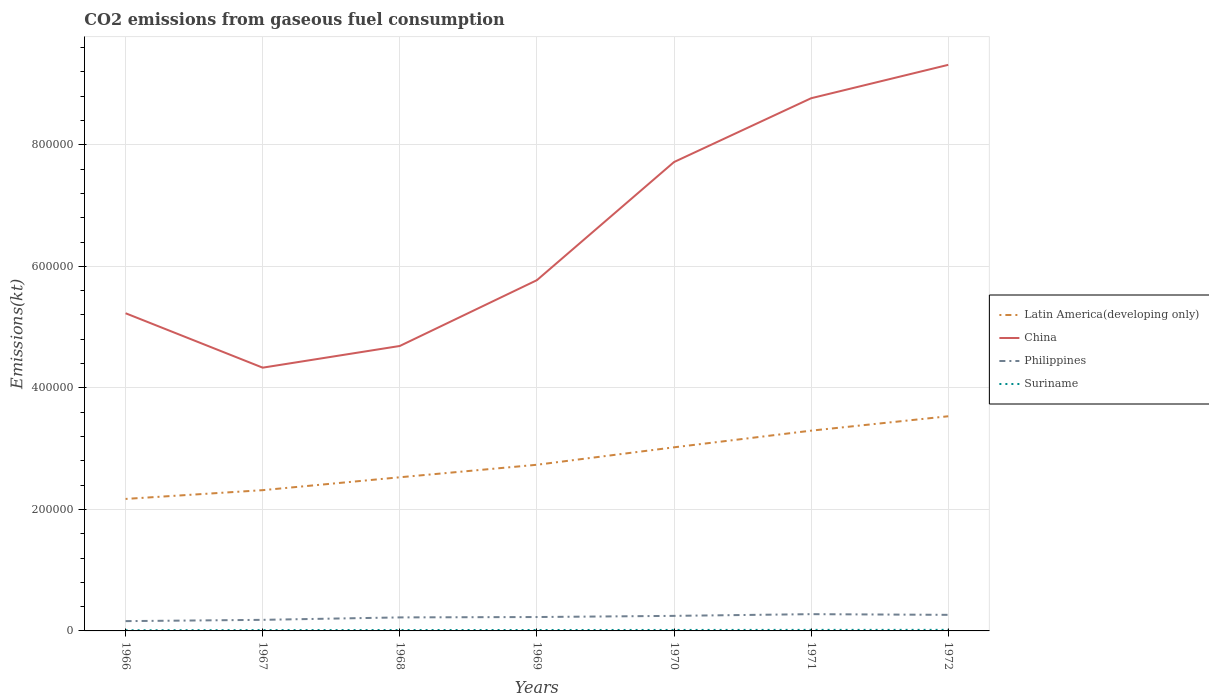How many different coloured lines are there?
Give a very brief answer. 4. Does the line corresponding to Philippines intersect with the line corresponding to China?
Offer a terse response. No. Across all years, what is the maximum amount of CO2 emitted in Latin America(developing only)?
Your response must be concise. 2.17e+05. In which year was the amount of CO2 emitted in Suriname maximum?
Offer a terse response. 1966. What is the total amount of CO2 emitted in Suriname in the graph?
Provide a succinct answer. -29.34. What is the difference between the highest and the second highest amount of CO2 emitted in Suriname?
Provide a succinct answer. 649.06. How many lines are there?
Keep it short and to the point. 4. How many years are there in the graph?
Offer a very short reply. 7. What is the difference between two consecutive major ticks on the Y-axis?
Your answer should be very brief. 2.00e+05. Are the values on the major ticks of Y-axis written in scientific E-notation?
Your response must be concise. No. Does the graph contain any zero values?
Your answer should be very brief. No. What is the title of the graph?
Your answer should be very brief. CO2 emissions from gaseous fuel consumption. What is the label or title of the Y-axis?
Provide a succinct answer. Emissions(kt). What is the Emissions(kt) in Latin America(developing only) in 1966?
Offer a terse response. 2.17e+05. What is the Emissions(kt) of China in 1966?
Provide a succinct answer. 5.23e+05. What is the Emissions(kt) of Philippines in 1966?
Make the answer very short. 1.61e+04. What is the Emissions(kt) of Suriname in 1966?
Provide a succinct answer. 1096.43. What is the Emissions(kt) of Latin America(developing only) in 1967?
Offer a terse response. 2.32e+05. What is the Emissions(kt) in China in 1967?
Make the answer very short. 4.33e+05. What is the Emissions(kt) in Philippines in 1967?
Keep it short and to the point. 1.82e+04. What is the Emissions(kt) in Suriname in 1967?
Your response must be concise. 1334.79. What is the Emissions(kt) of Latin America(developing only) in 1968?
Your answer should be very brief. 2.53e+05. What is the Emissions(kt) in China in 1968?
Provide a succinct answer. 4.69e+05. What is the Emissions(kt) in Philippines in 1968?
Give a very brief answer. 2.23e+04. What is the Emissions(kt) in Suriname in 1968?
Ensure brevity in your answer.  1452.13. What is the Emissions(kt) in Latin America(developing only) in 1969?
Keep it short and to the point. 2.73e+05. What is the Emissions(kt) of China in 1969?
Your answer should be compact. 5.77e+05. What is the Emissions(kt) of Philippines in 1969?
Your response must be concise. 2.29e+04. What is the Emissions(kt) of Suriname in 1969?
Provide a short and direct response. 1521.81. What is the Emissions(kt) of Latin America(developing only) in 1970?
Keep it short and to the point. 3.02e+05. What is the Emissions(kt) of China in 1970?
Your answer should be compact. 7.72e+05. What is the Emissions(kt) of Philippines in 1970?
Offer a very short reply. 2.48e+04. What is the Emissions(kt) of Suriname in 1970?
Provide a short and direct response. 1609.81. What is the Emissions(kt) of Latin America(developing only) in 1971?
Make the answer very short. 3.30e+05. What is the Emissions(kt) in China in 1971?
Ensure brevity in your answer.  8.77e+05. What is the Emissions(kt) of Philippines in 1971?
Offer a terse response. 2.76e+04. What is the Emissions(kt) of Suriname in 1971?
Your answer should be compact. 1716.16. What is the Emissions(kt) of Latin America(developing only) in 1972?
Ensure brevity in your answer.  3.53e+05. What is the Emissions(kt) in China in 1972?
Provide a short and direct response. 9.32e+05. What is the Emissions(kt) of Philippines in 1972?
Ensure brevity in your answer.  2.64e+04. What is the Emissions(kt) of Suriname in 1972?
Your answer should be compact. 1745.49. Across all years, what is the maximum Emissions(kt) of Latin America(developing only)?
Keep it short and to the point. 3.53e+05. Across all years, what is the maximum Emissions(kt) in China?
Provide a succinct answer. 9.32e+05. Across all years, what is the maximum Emissions(kt) of Philippines?
Keep it short and to the point. 2.76e+04. Across all years, what is the maximum Emissions(kt) in Suriname?
Offer a very short reply. 1745.49. Across all years, what is the minimum Emissions(kt) of Latin America(developing only)?
Offer a very short reply. 2.17e+05. Across all years, what is the minimum Emissions(kt) in China?
Ensure brevity in your answer.  4.33e+05. Across all years, what is the minimum Emissions(kt) in Philippines?
Offer a terse response. 1.61e+04. Across all years, what is the minimum Emissions(kt) of Suriname?
Offer a terse response. 1096.43. What is the total Emissions(kt) of Latin America(developing only) in the graph?
Offer a terse response. 1.96e+06. What is the total Emissions(kt) of China in the graph?
Offer a very short reply. 4.58e+06. What is the total Emissions(kt) of Philippines in the graph?
Provide a succinct answer. 1.58e+05. What is the total Emissions(kt) in Suriname in the graph?
Your answer should be very brief. 1.05e+04. What is the difference between the Emissions(kt) in Latin America(developing only) in 1966 and that in 1967?
Provide a succinct answer. -1.44e+04. What is the difference between the Emissions(kt) of China in 1966 and that in 1967?
Your answer should be very brief. 8.96e+04. What is the difference between the Emissions(kt) in Philippines in 1966 and that in 1967?
Offer a very short reply. -2108.53. What is the difference between the Emissions(kt) of Suriname in 1966 and that in 1967?
Offer a very short reply. -238.35. What is the difference between the Emissions(kt) in Latin America(developing only) in 1966 and that in 1968?
Ensure brevity in your answer.  -3.56e+04. What is the difference between the Emissions(kt) of China in 1966 and that in 1968?
Keep it short and to the point. 5.39e+04. What is the difference between the Emissions(kt) in Philippines in 1966 and that in 1968?
Provide a succinct answer. -6127.56. What is the difference between the Emissions(kt) in Suriname in 1966 and that in 1968?
Keep it short and to the point. -355.7. What is the difference between the Emissions(kt) of Latin America(developing only) in 1966 and that in 1969?
Offer a terse response. -5.62e+04. What is the difference between the Emissions(kt) in China in 1966 and that in 1969?
Your answer should be compact. -5.44e+04. What is the difference between the Emissions(kt) of Philippines in 1966 and that in 1969?
Ensure brevity in your answer.  -6736.28. What is the difference between the Emissions(kt) in Suriname in 1966 and that in 1969?
Ensure brevity in your answer.  -425.37. What is the difference between the Emissions(kt) in Latin America(developing only) in 1966 and that in 1970?
Give a very brief answer. -8.49e+04. What is the difference between the Emissions(kt) of China in 1966 and that in 1970?
Your response must be concise. -2.49e+05. What is the difference between the Emissions(kt) of Philippines in 1966 and that in 1970?
Keep it short and to the point. -8657.79. What is the difference between the Emissions(kt) in Suriname in 1966 and that in 1970?
Ensure brevity in your answer.  -513.38. What is the difference between the Emissions(kt) in Latin America(developing only) in 1966 and that in 1971?
Offer a terse response. -1.12e+05. What is the difference between the Emissions(kt) of China in 1966 and that in 1971?
Your answer should be compact. -3.54e+05. What is the difference between the Emissions(kt) of Philippines in 1966 and that in 1971?
Your answer should be compact. -1.15e+04. What is the difference between the Emissions(kt) of Suriname in 1966 and that in 1971?
Your response must be concise. -619.72. What is the difference between the Emissions(kt) of Latin America(developing only) in 1966 and that in 1972?
Make the answer very short. -1.36e+05. What is the difference between the Emissions(kt) in China in 1966 and that in 1972?
Provide a short and direct response. -4.09e+05. What is the difference between the Emissions(kt) of Philippines in 1966 and that in 1972?
Make the answer very short. -1.03e+04. What is the difference between the Emissions(kt) of Suriname in 1966 and that in 1972?
Your response must be concise. -649.06. What is the difference between the Emissions(kt) of Latin America(developing only) in 1967 and that in 1968?
Offer a terse response. -2.12e+04. What is the difference between the Emissions(kt) of China in 1967 and that in 1968?
Offer a terse response. -3.57e+04. What is the difference between the Emissions(kt) of Philippines in 1967 and that in 1968?
Offer a terse response. -4019.03. What is the difference between the Emissions(kt) in Suriname in 1967 and that in 1968?
Make the answer very short. -117.34. What is the difference between the Emissions(kt) of Latin America(developing only) in 1967 and that in 1969?
Make the answer very short. -4.18e+04. What is the difference between the Emissions(kt) in China in 1967 and that in 1969?
Ensure brevity in your answer.  -1.44e+05. What is the difference between the Emissions(kt) of Philippines in 1967 and that in 1969?
Provide a succinct answer. -4627.75. What is the difference between the Emissions(kt) in Suriname in 1967 and that in 1969?
Offer a very short reply. -187.02. What is the difference between the Emissions(kt) of Latin America(developing only) in 1967 and that in 1970?
Keep it short and to the point. -7.05e+04. What is the difference between the Emissions(kt) of China in 1967 and that in 1970?
Provide a succinct answer. -3.38e+05. What is the difference between the Emissions(kt) of Philippines in 1967 and that in 1970?
Keep it short and to the point. -6549.26. What is the difference between the Emissions(kt) in Suriname in 1967 and that in 1970?
Offer a terse response. -275.02. What is the difference between the Emissions(kt) in Latin America(developing only) in 1967 and that in 1971?
Provide a short and direct response. -9.79e+04. What is the difference between the Emissions(kt) of China in 1967 and that in 1971?
Give a very brief answer. -4.43e+05. What is the difference between the Emissions(kt) in Philippines in 1967 and that in 1971?
Give a very brief answer. -9354.52. What is the difference between the Emissions(kt) in Suriname in 1967 and that in 1971?
Provide a short and direct response. -381.37. What is the difference between the Emissions(kt) in Latin America(developing only) in 1967 and that in 1972?
Provide a succinct answer. -1.22e+05. What is the difference between the Emissions(kt) of China in 1967 and that in 1972?
Offer a terse response. -4.98e+05. What is the difference between the Emissions(kt) of Philippines in 1967 and that in 1972?
Provide a succinct answer. -8210.41. What is the difference between the Emissions(kt) in Suriname in 1967 and that in 1972?
Make the answer very short. -410.7. What is the difference between the Emissions(kt) in Latin America(developing only) in 1968 and that in 1969?
Give a very brief answer. -2.06e+04. What is the difference between the Emissions(kt) in China in 1968 and that in 1969?
Give a very brief answer. -1.08e+05. What is the difference between the Emissions(kt) in Philippines in 1968 and that in 1969?
Provide a short and direct response. -608.72. What is the difference between the Emissions(kt) in Suriname in 1968 and that in 1969?
Provide a succinct answer. -69.67. What is the difference between the Emissions(kt) in Latin America(developing only) in 1968 and that in 1970?
Your answer should be compact. -4.93e+04. What is the difference between the Emissions(kt) in China in 1968 and that in 1970?
Keep it short and to the point. -3.03e+05. What is the difference between the Emissions(kt) in Philippines in 1968 and that in 1970?
Your response must be concise. -2530.23. What is the difference between the Emissions(kt) in Suriname in 1968 and that in 1970?
Ensure brevity in your answer.  -157.68. What is the difference between the Emissions(kt) in Latin America(developing only) in 1968 and that in 1971?
Keep it short and to the point. -7.67e+04. What is the difference between the Emissions(kt) of China in 1968 and that in 1971?
Provide a succinct answer. -4.08e+05. What is the difference between the Emissions(kt) of Philippines in 1968 and that in 1971?
Provide a succinct answer. -5335.48. What is the difference between the Emissions(kt) of Suriname in 1968 and that in 1971?
Make the answer very short. -264.02. What is the difference between the Emissions(kt) in Latin America(developing only) in 1968 and that in 1972?
Offer a very short reply. -1.00e+05. What is the difference between the Emissions(kt) of China in 1968 and that in 1972?
Provide a succinct answer. -4.63e+05. What is the difference between the Emissions(kt) in Philippines in 1968 and that in 1972?
Your response must be concise. -4191.38. What is the difference between the Emissions(kt) in Suriname in 1968 and that in 1972?
Offer a very short reply. -293.36. What is the difference between the Emissions(kt) in Latin America(developing only) in 1969 and that in 1970?
Your answer should be very brief. -2.87e+04. What is the difference between the Emissions(kt) of China in 1969 and that in 1970?
Provide a succinct answer. -1.94e+05. What is the difference between the Emissions(kt) in Philippines in 1969 and that in 1970?
Ensure brevity in your answer.  -1921.51. What is the difference between the Emissions(kt) in Suriname in 1969 and that in 1970?
Keep it short and to the point. -88.01. What is the difference between the Emissions(kt) in Latin America(developing only) in 1969 and that in 1971?
Provide a succinct answer. -5.61e+04. What is the difference between the Emissions(kt) in China in 1969 and that in 1971?
Make the answer very short. -2.99e+05. What is the difference between the Emissions(kt) of Philippines in 1969 and that in 1971?
Keep it short and to the point. -4726.76. What is the difference between the Emissions(kt) in Suriname in 1969 and that in 1971?
Your response must be concise. -194.35. What is the difference between the Emissions(kt) of Latin America(developing only) in 1969 and that in 1972?
Keep it short and to the point. -7.98e+04. What is the difference between the Emissions(kt) of China in 1969 and that in 1972?
Give a very brief answer. -3.54e+05. What is the difference between the Emissions(kt) in Philippines in 1969 and that in 1972?
Provide a short and direct response. -3582.66. What is the difference between the Emissions(kt) in Suriname in 1969 and that in 1972?
Your response must be concise. -223.69. What is the difference between the Emissions(kt) in Latin America(developing only) in 1970 and that in 1971?
Provide a short and direct response. -2.74e+04. What is the difference between the Emissions(kt) of China in 1970 and that in 1971?
Give a very brief answer. -1.05e+05. What is the difference between the Emissions(kt) in Philippines in 1970 and that in 1971?
Your answer should be very brief. -2805.26. What is the difference between the Emissions(kt) of Suriname in 1970 and that in 1971?
Give a very brief answer. -106.34. What is the difference between the Emissions(kt) in Latin America(developing only) in 1970 and that in 1972?
Make the answer very short. -5.11e+04. What is the difference between the Emissions(kt) in China in 1970 and that in 1972?
Offer a very short reply. -1.60e+05. What is the difference between the Emissions(kt) in Philippines in 1970 and that in 1972?
Keep it short and to the point. -1661.15. What is the difference between the Emissions(kt) of Suriname in 1970 and that in 1972?
Keep it short and to the point. -135.68. What is the difference between the Emissions(kt) of Latin America(developing only) in 1971 and that in 1972?
Your response must be concise. -2.37e+04. What is the difference between the Emissions(kt) of China in 1971 and that in 1972?
Your response must be concise. -5.49e+04. What is the difference between the Emissions(kt) of Philippines in 1971 and that in 1972?
Provide a succinct answer. 1144.1. What is the difference between the Emissions(kt) of Suriname in 1971 and that in 1972?
Keep it short and to the point. -29.34. What is the difference between the Emissions(kt) in Latin America(developing only) in 1966 and the Emissions(kt) in China in 1967?
Ensure brevity in your answer.  -2.16e+05. What is the difference between the Emissions(kt) of Latin America(developing only) in 1966 and the Emissions(kt) of Philippines in 1967?
Give a very brief answer. 1.99e+05. What is the difference between the Emissions(kt) in Latin America(developing only) in 1966 and the Emissions(kt) in Suriname in 1967?
Your answer should be compact. 2.16e+05. What is the difference between the Emissions(kt) in China in 1966 and the Emissions(kt) in Philippines in 1967?
Your answer should be compact. 5.05e+05. What is the difference between the Emissions(kt) in China in 1966 and the Emissions(kt) in Suriname in 1967?
Offer a very short reply. 5.21e+05. What is the difference between the Emissions(kt) of Philippines in 1966 and the Emissions(kt) of Suriname in 1967?
Offer a very short reply. 1.48e+04. What is the difference between the Emissions(kt) of Latin America(developing only) in 1966 and the Emissions(kt) of China in 1968?
Give a very brief answer. -2.52e+05. What is the difference between the Emissions(kt) of Latin America(developing only) in 1966 and the Emissions(kt) of Philippines in 1968?
Provide a succinct answer. 1.95e+05. What is the difference between the Emissions(kt) of Latin America(developing only) in 1966 and the Emissions(kt) of Suriname in 1968?
Ensure brevity in your answer.  2.16e+05. What is the difference between the Emissions(kt) in China in 1966 and the Emissions(kt) in Philippines in 1968?
Your answer should be compact. 5.01e+05. What is the difference between the Emissions(kt) of China in 1966 and the Emissions(kt) of Suriname in 1968?
Keep it short and to the point. 5.21e+05. What is the difference between the Emissions(kt) of Philippines in 1966 and the Emissions(kt) of Suriname in 1968?
Give a very brief answer. 1.47e+04. What is the difference between the Emissions(kt) in Latin America(developing only) in 1966 and the Emissions(kt) in China in 1969?
Ensure brevity in your answer.  -3.60e+05. What is the difference between the Emissions(kt) of Latin America(developing only) in 1966 and the Emissions(kt) of Philippines in 1969?
Give a very brief answer. 1.94e+05. What is the difference between the Emissions(kt) of Latin America(developing only) in 1966 and the Emissions(kt) of Suriname in 1969?
Keep it short and to the point. 2.16e+05. What is the difference between the Emissions(kt) in China in 1966 and the Emissions(kt) in Philippines in 1969?
Your answer should be very brief. 5.00e+05. What is the difference between the Emissions(kt) in China in 1966 and the Emissions(kt) in Suriname in 1969?
Your answer should be compact. 5.21e+05. What is the difference between the Emissions(kt) of Philippines in 1966 and the Emissions(kt) of Suriname in 1969?
Make the answer very short. 1.46e+04. What is the difference between the Emissions(kt) of Latin America(developing only) in 1966 and the Emissions(kt) of China in 1970?
Give a very brief answer. -5.54e+05. What is the difference between the Emissions(kt) in Latin America(developing only) in 1966 and the Emissions(kt) in Philippines in 1970?
Keep it short and to the point. 1.92e+05. What is the difference between the Emissions(kt) of Latin America(developing only) in 1966 and the Emissions(kt) of Suriname in 1970?
Make the answer very short. 2.16e+05. What is the difference between the Emissions(kt) in China in 1966 and the Emissions(kt) in Philippines in 1970?
Your answer should be compact. 4.98e+05. What is the difference between the Emissions(kt) in China in 1966 and the Emissions(kt) in Suriname in 1970?
Your response must be concise. 5.21e+05. What is the difference between the Emissions(kt) of Philippines in 1966 and the Emissions(kt) of Suriname in 1970?
Your response must be concise. 1.45e+04. What is the difference between the Emissions(kt) in Latin America(developing only) in 1966 and the Emissions(kt) in China in 1971?
Ensure brevity in your answer.  -6.59e+05. What is the difference between the Emissions(kt) in Latin America(developing only) in 1966 and the Emissions(kt) in Philippines in 1971?
Provide a short and direct response. 1.90e+05. What is the difference between the Emissions(kt) of Latin America(developing only) in 1966 and the Emissions(kt) of Suriname in 1971?
Offer a very short reply. 2.15e+05. What is the difference between the Emissions(kt) of China in 1966 and the Emissions(kt) of Philippines in 1971?
Offer a very short reply. 4.95e+05. What is the difference between the Emissions(kt) of China in 1966 and the Emissions(kt) of Suriname in 1971?
Ensure brevity in your answer.  5.21e+05. What is the difference between the Emissions(kt) of Philippines in 1966 and the Emissions(kt) of Suriname in 1971?
Keep it short and to the point. 1.44e+04. What is the difference between the Emissions(kt) in Latin America(developing only) in 1966 and the Emissions(kt) in China in 1972?
Give a very brief answer. -7.14e+05. What is the difference between the Emissions(kt) of Latin America(developing only) in 1966 and the Emissions(kt) of Philippines in 1972?
Provide a succinct answer. 1.91e+05. What is the difference between the Emissions(kt) of Latin America(developing only) in 1966 and the Emissions(kt) of Suriname in 1972?
Provide a succinct answer. 2.15e+05. What is the difference between the Emissions(kt) in China in 1966 and the Emissions(kt) in Philippines in 1972?
Offer a terse response. 4.96e+05. What is the difference between the Emissions(kt) in China in 1966 and the Emissions(kt) in Suriname in 1972?
Keep it short and to the point. 5.21e+05. What is the difference between the Emissions(kt) in Philippines in 1966 and the Emissions(kt) in Suriname in 1972?
Provide a short and direct response. 1.44e+04. What is the difference between the Emissions(kt) of Latin America(developing only) in 1967 and the Emissions(kt) of China in 1968?
Provide a short and direct response. -2.37e+05. What is the difference between the Emissions(kt) of Latin America(developing only) in 1967 and the Emissions(kt) of Philippines in 1968?
Offer a very short reply. 2.09e+05. What is the difference between the Emissions(kt) in Latin America(developing only) in 1967 and the Emissions(kt) in Suriname in 1968?
Your response must be concise. 2.30e+05. What is the difference between the Emissions(kt) in China in 1967 and the Emissions(kt) in Philippines in 1968?
Offer a terse response. 4.11e+05. What is the difference between the Emissions(kt) of China in 1967 and the Emissions(kt) of Suriname in 1968?
Offer a very short reply. 4.32e+05. What is the difference between the Emissions(kt) of Philippines in 1967 and the Emissions(kt) of Suriname in 1968?
Your answer should be compact. 1.68e+04. What is the difference between the Emissions(kt) of Latin America(developing only) in 1967 and the Emissions(kt) of China in 1969?
Provide a succinct answer. -3.46e+05. What is the difference between the Emissions(kt) of Latin America(developing only) in 1967 and the Emissions(kt) of Philippines in 1969?
Keep it short and to the point. 2.09e+05. What is the difference between the Emissions(kt) of Latin America(developing only) in 1967 and the Emissions(kt) of Suriname in 1969?
Your response must be concise. 2.30e+05. What is the difference between the Emissions(kt) in China in 1967 and the Emissions(kt) in Philippines in 1969?
Keep it short and to the point. 4.10e+05. What is the difference between the Emissions(kt) in China in 1967 and the Emissions(kt) in Suriname in 1969?
Give a very brief answer. 4.32e+05. What is the difference between the Emissions(kt) of Philippines in 1967 and the Emissions(kt) of Suriname in 1969?
Provide a succinct answer. 1.67e+04. What is the difference between the Emissions(kt) of Latin America(developing only) in 1967 and the Emissions(kt) of China in 1970?
Provide a succinct answer. -5.40e+05. What is the difference between the Emissions(kt) in Latin America(developing only) in 1967 and the Emissions(kt) in Philippines in 1970?
Your response must be concise. 2.07e+05. What is the difference between the Emissions(kt) of Latin America(developing only) in 1967 and the Emissions(kt) of Suriname in 1970?
Ensure brevity in your answer.  2.30e+05. What is the difference between the Emissions(kt) in China in 1967 and the Emissions(kt) in Philippines in 1970?
Provide a short and direct response. 4.08e+05. What is the difference between the Emissions(kt) of China in 1967 and the Emissions(kt) of Suriname in 1970?
Offer a very short reply. 4.32e+05. What is the difference between the Emissions(kt) in Philippines in 1967 and the Emissions(kt) in Suriname in 1970?
Your answer should be very brief. 1.66e+04. What is the difference between the Emissions(kt) of Latin America(developing only) in 1967 and the Emissions(kt) of China in 1971?
Make the answer very short. -6.45e+05. What is the difference between the Emissions(kt) of Latin America(developing only) in 1967 and the Emissions(kt) of Philippines in 1971?
Your answer should be very brief. 2.04e+05. What is the difference between the Emissions(kt) in Latin America(developing only) in 1967 and the Emissions(kt) in Suriname in 1971?
Offer a very short reply. 2.30e+05. What is the difference between the Emissions(kt) of China in 1967 and the Emissions(kt) of Philippines in 1971?
Provide a succinct answer. 4.06e+05. What is the difference between the Emissions(kt) in China in 1967 and the Emissions(kt) in Suriname in 1971?
Provide a short and direct response. 4.32e+05. What is the difference between the Emissions(kt) of Philippines in 1967 and the Emissions(kt) of Suriname in 1971?
Offer a terse response. 1.65e+04. What is the difference between the Emissions(kt) in Latin America(developing only) in 1967 and the Emissions(kt) in China in 1972?
Provide a short and direct response. -7.00e+05. What is the difference between the Emissions(kt) of Latin America(developing only) in 1967 and the Emissions(kt) of Philippines in 1972?
Offer a very short reply. 2.05e+05. What is the difference between the Emissions(kt) of Latin America(developing only) in 1967 and the Emissions(kt) of Suriname in 1972?
Ensure brevity in your answer.  2.30e+05. What is the difference between the Emissions(kt) of China in 1967 and the Emissions(kt) of Philippines in 1972?
Your response must be concise. 4.07e+05. What is the difference between the Emissions(kt) of China in 1967 and the Emissions(kt) of Suriname in 1972?
Ensure brevity in your answer.  4.31e+05. What is the difference between the Emissions(kt) in Philippines in 1967 and the Emissions(kt) in Suriname in 1972?
Keep it short and to the point. 1.65e+04. What is the difference between the Emissions(kt) of Latin America(developing only) in 1968 and the Emissions(kt) of China in 1969?
Offer a very short reply. -3.24e+05. What is the difference between the Emissions(kt) of Latin America(developing only) in 1968 and the Emissions(kt) of Philippines in 1969?
Provide a succinct answer. 2.30e+05. What is the difference between the Emissions(kt) in Latin America(developing only) in 1968 and the Emissions(kt) in Suriname in 1969?
Make the answer very short. 2.51e+05. What is the difference between the Emissions(kt) in China in 1968 and the Emissions(kt) in Philippines in 1969?
Ensure brevity in your answer.  4.46e+05. What is the difference between the Emissions(kt) of China in 1968 and the Emissions(kt) of Suriname in 1969?
Give a very brief answer. 4.67e+05. What is the difference between the Emissions(kt) in Philippines in 1968 and the Emissions(kt) in Suriname in 1969?
Make the answer very short. 2.07e+04. What is the difference between the Emissions(kt) in Latin America(developing only) in 1968 and the Emissions(kt) in China in 1970?
Your answer should be very brief. -5.19e+05. What is the difference between the Emissions(kt) in Latin America(developing only) in 1968 and the Emissions(kt) in Philippines in 1970?
Give a very brief answer. 2.28e+05. What is the difference between the Emissions(kt) of Latin America(developing only) in 1968 and the Emissions(kt) of Suriname in 1970?
Offer a very short reply. 2.51e+05. What is the difference between the Emissions(kt) of China in 1968 and the Emissions(kt) of Philippines in 1970?
Provide a succinct answer. 4.44e+05. What is the difference between the Emissions(kt) in China in 1968 and the Emissions(kt) in Suriname in 1970?
Offer a very short reply. 4.67e+05. What is the difference between the Emissions(kt) of Philippines in 1968 and the Emissions(kt) of Suriname in 1970?
Offer a terse response. 2.06e+04. What is the difference between the Emissions(kt) in Latin America(developing only) in 1968 and the Emissions(kt) in China in 1971?
Provide a succinct answer. -6.24e+05. What is the difference between the Emissions(kt) in Latin America(developing only) in 1968 and the Emissions(kt) in Philippines in 1971?
Offer a terse response. 2.25e+05. What is the difference between the Emissions(kt) in Latin America(developing only) in 1968 and the Emissions(kt) in Suriname in 1971?
Provide a short and direct response. 2.51e+05. What is the difference between the Emissions(kt) in China in 1968 and the Emissions(kt) in Philippines in 1971?
Keep it short and to the point. 4.41e+05. What is the difference between the Emissions(kt) in China in 1968 and the Emissions(kt) in Suriname in 1971?
Your answer should be very brief. 4.67e+05. What is the difference between the Emissions(kt) of Philippines in 1968 and the Emissions(kt) of Suriname in 1971?
Provide a short and direct response. 2.05e+04. What is the difference between the Emissions(kt) in Latin America(developing only) in 1968 and the Emissions(kt) in China in 1972?
Your answer should be very brief. -6.79e+05. What is the difference between the Emissions(kt) of Latin America(developing only) in 1968 and the Emissions(kt) of Philippines in 1972?
Your answer should be very brief. 2.26e+05. What is the difference between the Emissions(kt) in Latin America(developing only) in 1968 and the Emissions(kt) in Suriname in 1972?
Make the answer very short. 2.51e+05. What is the difference between the Emissions(kt) in China in 1968 and the Emissions(kt) in Philippines in 1972?
Keep it short and to the point. 4.42e+05. What is the difference between the Emissions(kt) in China in 1968 and the Emissions(kt) in Suriname in 1972?
Make the answer very short. 4.67e+05. What is the difference between the Emissions(kt) of Philippines in 1968 and the Emissions(kt) of Suriname in 1972?
Make the answer very short. 2.05e+04. What is the difference between the Emissions(kt) in Latin America(developing only) in 1969 and the Emissions(kt) in China in 1970?
Provide a succinct answer. -4.98e+05. What is the difference between the Emissions(kt) in Latin America(developing only) in 1969 and the Emissions(kt) in Philippines in 1970?
Offer a very short reply. 2.49e+05. What is the difference between the Emissions(kt) in Latin America(developing only) in 1969 and the Emissions(kt) in Suriname in 1970?
Offer a very short reply. 2.72e+05. What is the difference between the Emissions(kt) in China in 1969 and the Emissions(kt) in Philippines in 1970?
Provide a short and direct response. 5.52e+05. What is the difference between the Emissions(kt) of China in 1969 and the Emissions(kt) of Suriname in 1970?
Make the answer very short. 5.76e+05. What is the difference between the Emissions(kt) in Philippines in 1969 and the Emissions(kt) in Suriname in 1970?
Give a very brief answer. 2.13e+04. What is the difference between the Emissions(kt) in Latin America(developing only) in 1969 and the Emissions(kt) in China in 1971?
Your answer should be compact. -6.03e+05. What is the difference between the Emissions(kt) of Latin America(developing only) in 1969 and the Emissions(kt) of Philippines in 1971?
Keep it short and to the point. 2.46e+05. What is the difference between the Emissions(kt) in Latin America(developing only) in 1969 and the Emissions(kt) in Suriname in 1971?
Your answer should be very brief. 2.72e+05. What is the difference between the Emissions(kt) in China in 1969 and the Emissions(kt) in Philippines in 1971?
Your answer should be compact. 5.50e+05. What is the difference between the Emissions(kt) of China in 1969 and the Emissions(kt) of Suriname in 1971?
Keep it short and to the point. 5.76e+05. What is the difference between the Emissions(kt) in Philippines in 1969 and the Emissions(kt) in Suriname in 1971?
Provide a succinct answer. 2.11e+04. What is the difference between the Emissions(kt) of Latin America(developing only) in 1969 and the Emissions(kt) of China in 1972?
Your answer should be very brief. -6.58e+05. What is the difference between the Emissions(kt) in Latin America(developing only) in 1969 and the Emissions(kt) in Philippines in 1972?
Keep it short and to the point. 2.47e+05. What is the difference between the Emissions(kt) of Latin America(developing only) in 1969 and the Emissions(kt) of Suriname in 1972?
Provide a short and direct response. 2.72e+05. What is the difference between the Emissions(kt) in China in 1969 and the Emissions(kt) in Philippines in 1972?
Your response must be concise. 5.51e+05. What is the difference between the Emissions(kt) of China in 1969 and the Emissions(kt) of Suriname in 1972?
Your response must be concise. 5.75e+05. What is the difference between the Emissions(kt) in Philippines in 1969 and the Emissions(kt) in Suriname in 1972?
Ensure brevity in your answer.  2.11e+04. What is the difference between the Emissions(kt) of Latin America(developing only) in 1970 and the Emissions(kt) of China in 1971?
Your response must be concise. -5.74e+05. What is the difference between the Emissions(kt) in Latin America(developing only) in 1970 and the Emissions(kt) in Philippines in 1971?
Make the answer very short. 2.75e+05. What is the difference between the Emissions(kt) of Latin America(developing only) in 1970 and the Emissions(kt) of Suriname in 1971?
Give a very brief answer. 3.00e+05. What is the difference between the Emissions(kt) of China in 1970 and the Emissions(kt) of Philippines in 1971?
Offer a terse response. 7.44e+05. What is the difference between the Emissions(kt) of China in 1970 and the Emissions(kt) of Suriname in 1971?
Keep it short and to the point. 7.70e+05. What is the difference between the Emissions(kt) in Philippines in 1970 and the Emissions(kt) in Suriname in 1971?
Ensure brevity in your answer.  2.31e+04. What is the difference between the Emissions(kt) of Latin America(developing only) in 1970 and the Emissions(kt) of China in 1972?
Your response must be concise. -6.29e+05. What is the difference between the Emissions(kt) of Latin America(developing only) in 1970 and the Emissions(kt) of Philippines in 1972?
Make the answer very short. 2.76e+05. What is the difference between the Emissions(kt) in Latin America(developing only) in 1970 and the Emissions(kt) in Suriname in 1972?
Offer a terse response. 3.00e+05. What is the difference between the Emissions(kt) in China in 1970 and the Emissions(kt) in Philippines in 1972?
Offer a very short reply. 7.45e+05. What is the difference between the Emissions(kt) in China in 1970 and the Emissions(kt) in Suriname in 1972?
Make the answer very short. 7.70e+05. What is the difference between the Emissions(kt) of Philippines in 1970 and the Emissions(kt) of Suriname in 1972?
Your answer should be very brief. 2.30e+04. What is the difference between the Emissions(kt) in Latin America(developing only) in 1971 and the Emissions(kt) in China in 1972?
Your answer should be very brief. -6.02e+05. What is the difference between the Emissions(kt) of Latin America(developing only) in 1971 and the Emissions(kt) of Philippines in 1972?
Provide a short and direct response. 3.03e+05. What is the difference between the Emissions(kt) of Latin America(developing only) in 1971 and the Emissions(kt) of Suriname in 1972?
Offer a terse response. 3.28e+05. What is the difference between the Emissions(kt) in China in 1971 and the Emissions(kt) in Philippines in 1972?
Give a very brief answer. 8.50e+05. What is the difference between the Emissions(kt) in China in 1971 and the Emissions(kt) in Suriname in 1972?
Your answer should be compact. 8.75e+05. What is the difference between the Emissions(kt) in Philippines in 1971 and the Emissions(kt) in Suriname in 1972?
Your response must be concise. 2.58e+04. What is the average Emissions(kt) in Latin America(developing only) per year?
Give a very brief answer. 2.80e+05. What is the average Emissions(kt) of China per year?
Make the answer very short. 6.55e+05. What is the average Emissions(kt) in Philippines per year?
Your answer should be compact. 2.26e+04. What is the average Emissions(kt) in Suriname per year?
Your response must be concise. 1496.66. In the year 1966, what is the difference between the Emissions(kt) of Latin America(developing only) and Emissions(kt) of China?
Your answer should be very brief. -3.06e+05. In the year 1966, what is the difference between the Emissions(kt) of Latin America(developing only) and Emissions(kt) of Philippines?
Your answer should be compact. 2.01e+05. In the year 1966, what is the difference between the Emissions(kt) of Latin America(developing only) and Emissions(kt) of Suriname?
Provide a succinct answer. 2.16e+05. In the year 1966, what is the difference between the Emissions(kt) in China and Emissions(kt) in Philippines?
Offer a terse response. 5.07e+05. In the year 1966, what is the difference between the Emissions(kt) in China and Emissions(kt) in Suriname?
Provide a short and direct response. 5.22e+05. In the year 1966, what is the difference between the Emissions(kt) in Philippines and Emissions(kt) in Suriname?
Provide a short and direct response. 1.50e+04. In the year 1967, what is the difference between the Emissions(kt) of Latin America(developing only) and Emissions(kt) of China?
Keep it short and to the point. -2.02e+05. In the year 1967, what is the difference between the Emissions(kt) in Latin America(developing only) and Emissions(kt) in Philippines?
Provide a short and direct response. 2.13e+05. In the year 1967, what is the difference between the Emissions(kt) in Latin America(developing only) and Emissions(kt) in Suriname?
Your answer should be compact. 2.30e+05. In the year 1967, what is the difference between the Emissions(kt) of China and Emissions(kt) of Philippines?
Offer a terse response. 4.15e+05. In the year 1967, what is the difference between the Emissions(kt) of China and Emissions(kt) of Suriname?
Offer a very short reply. 4.32e+05. In the year 1967, what is the difference between the Emissions(kt) in Philippines and Emissions(kt) in Suriname?
Give a very brief answer. 1.69e+04. In the year 1968, what is the difference between the Emissions(kt) of Latin America(developing only) and Emissions(kt) of China?
Keep it short and to the point. -2.16e+05. In the year 1968, what is the difference between the Emissions(kt) in Latin America(developing only) and Emissions(kt) in Philippines?
Your response must be concise. 2.31e+05. In the year 1968, what is the difference between the Emissions(kt) of Latin America(developing only) and Emissions(kt) of Suriname?
Ensure brevity in your answer.  2.51e+05. In the year 1968, what is the difference between the Emissions(kt) in China and Emissions(kt) in Philippines?
Keep it short and to the point. 4.47e+05. In the year 1968, what is the difference between the Emissions(kt) in China and Emissions(kt) in Suriname?
Provide a short and direct response. 4.67e+05. In the year 1968, what is the difference between the Emissions(kt) of Philippines and Emissions(kt) of Suriname?
Your response must be concise. 2.08e+04. In the year 1969, what is the difference between the Emissions(kt) of Latin America(developing only) and Emissions(kt) of China?
Provide a short and direct response. -3.04e+05. In the year 1969, what is the difference between the Emissions(kt) of Latin America(developing only) and Emissions(kt) of Philippines?
Your answer should be compact. 2.51e+05. In the year 1969, what is the difference between the Emissions(kt) in Latin America(developing only) and Emissions(kt) in Suriname?
Provide a succinct answer. 2.72e+05. In the year 1969, what is the difference between the Emissions(kt) in China and Emissions(kt) in Philippines?
Keep it short and to the point. 5.54e+05. In the year 1969, what is the difference between the Emissions(kt) of China and Emissions(kt) of Suriname?
Your response must be concise. 5.76e+05. In the year 1969, what is the difference between the Emissions(kt) in Philippines and Emissions(kt) in Suriname?
Your answer should be compact. 2.13e+04. In the year 1970, what is the difference between the Emissions(kt) of Latin America(developing only) and Emissions(kt) of China?
Provide a succinct answer. -4.69e+05. In the year 1970, what is the difference between the Emissions(kt) of Latin America(developing only) and Emissions(kt) of Philippines?
Provide a short and direct response. 2.77e+05. In the year 1970, what is the difference between the Emissions(kt) of Latin America(developing only) and Emissions(kt) of Suriname?
Make the answer very short. 3.01e+05. In the year 1970, what is the difference between the Emissions(kt) of China and Emissions(kt) of Philippines?
Your answer should be very brief. 7.47e+05. In the year 1970, what is the difference between the Emissions(kt) of China and Emissions(kt) of Suriname?
Offer a terse response. 7.70e+05. In the year 1970, what is the difference between the Emissions(kt) in Philippines and Emissions(kt) in Suriname?
Make the answer very short. 2.32e+04. In the year 1971, what is the difference between the Emissions(kt) in Latin America(developing only) and Emissions(kt) in China?
Make the answer very short. -5.47e+05. In the year 1971, what is the difference between the Emissions(kt) in Latin America(developing only) and Emissions(kt) in Philippines?
Offer a terse response. 3.02e+05. In the year 1971, what is the difference between the Emissions(kt) in Latin America(developing only) and Emissions(kt) in Suriname?
Give a very brief answer. 3.28e+05. In the year 1971, what is the difference between the Emissions(kt) of China and Emissions(kt) of Philippines?
Offer a terse response. 8.49e+05. In the year 1971, what is the difference between the Emissions(kt) of China and Emissions(kt) of Suriname?
Ensure brevity in your answer.  8.75e+05. In the year 1971, what is the difference between the Emissions(kt) in Philippines and Emissions(kt) in Suriname?
Provide a succinct answer. 2.59e+04. In the year 1972, what is the difference between the Emissions(kt) in Latin America(developing only) and Emissions(kt) in China?
Your answer should be compact. -5.78e+05. In the year 1972, what is the difference between the Emissions(kt) of Latin America(developing only) and Emissions(kt) of Philippines?
Provide a short and direct response. 3.27e+05. In the year 1972, what is the difference between the Emissions(kt) in Latin America(developing only) and Emissions(kt) in Suriname?
Make the answer very short. 3.52e+05. In the year 1972, what is the difference between the Emissions(kt) of China and Emissions(kt) of Philippines?
Ensure brevity in your answer.  9.05e+05. In the year 1972, what is the difference between the Emissions(kt) in China and Emissions(kt) in Suriname?
Your response must be concise. 9.30e+05. In the year 1972, what is the difference between the Emissions(kt) of Philippines and Emissions(kt) of Suriname?
Offer a very short reply. 2.47e+04. What is the ratio of the Emissions(kt) in Latin America(developing only) in 1966 to that in 1967?
Your answer should be very brief. 0.94. What is the ratio of the Emissions(kt) of China in 1966 to that in 1967?
Provide a succinct answer. 1.21. What is the ratio of the Emissions(kt) of Philippines in 1966 to that in 1967?
Your response must be concise. 0.88. What is the ratio of the Emissions(kt) in Suriname in 1966 to that in 1967?
Offer a very short reply. 0.82. What is the ratio of the Emissions(kt) of Latin America(developing only) in 1966 to that in 1968?
Make the answer very short. 0.86. What is the ratio of the Emissions(kt) of China in 1966 to that in 1968?
Make the answer very short. 1.11. What is the ratio of the Emissions(kt) in Philippines in 1966 to that in 1968?
Your response must be concise. 0.72. What is the ratio of the Emissions(kt) in Suriname in 1966 to that in 1968?
Your answer should be compact. 0.76. What is the ratio of the Emissions(kt) in Latin America(developing only) in 1966 to that in 1969?
Provide a short and direct response. 0.79. What is the ratio of the Emissions(kt) of China in 1966 to that in 1969?
Provide a short and direct response. 0.91. What is the ratio of the Emissions(kt) in Philippines in 1966 to that in 1969?
Offer a very short reply. 0.71. What is the ratio of the Emissions(kt) in Suriname in 1966 to that in 1969?
Ensure brevity in your answer.  0.72. What is the ratio of the Emissions(kt) in Latin America(developing only) in 1966 to that in 1970?
Provide a succinct answer. 0.72. What is the ratio of the Emissions(kt) in China in 1966 to that in 1970?
Keep it short and to the point. 0.68. What is the ratio of the Emissions(kt) in Philippines in 1966 to that in 1970?
Your answer should be compact. 0.65. What is the ratio of the Emissions(kt) in Suriname in 1966 to that in 1970?
Make the answer very short. 0.68. What is the ratio of the Emissions(kt) in Latin America(developing only) in 1966 to that in 1971?
Provide a short and direct response. 0.66. What is the ratio of the Emissions(kt) in China in 1966 to that in 1971?
Provide a succinct answer. 0.6. What is the ratio of the Emissions(kt) of Philippines in 1966 to that in 1971?
Your response must be concise. 0.58. What is the ratio of the Emissions(kt) of Suriname in 1966 to that in 1971?
Provide a succinct answer. 0.64. What is the ratio of the Emissions(kt) in Latin America(developing only) in 1966 to that in 1972?
Make the answer very short. 0.61. What is the ratio of the Emissions(kt) of China in 1966 to that in 1972?
Give a very brief answer. 0.56. What is the ratio of the Emissions(kt) of Philippines in 1966 to that in 1972?
Make the answer very short. 0.61. What is the ratio of the Emissions(kt) in Suriname in 1966 to that in 1972?
Your answer should be compact. 0.63. What is the ratio of the Emissions(kt) of Latin America(developing only) in 1967 to that in 1968?
Offer a very short reply. 0.92. What is the ratio of the Emissions(kt) of China in 1967 to that in 1968?
Provide a short and direct response. 0.92. What is the ratio of the Emissions(kt) of Philippines in 1967 to that in 1968?
Offer a terse response. 0.82. What is the ratio of the Emissions(kt) in Suriname in 1967 to that in 1968?
Offer a terse response. 0.92. What is the ratio of the Emissions(kt) in Latin America(developing only) in 1967 to that in 1969?
Provide a short and direct response. 0.85. What is the ratio of the Emissions(kt) in China in 1967 to that in 1969?
Offer a very short reply. 0.75. What is the ratio of the Emissions(kt) of Philippines in 1967 to that in 1969?
Your answer should be compact. 0.8. What is the ratio of the Emissions(kt) in Suriname in 1967 to that in 1969?
Provide a succinct answer. 0.88. What is the ratio of the Emissions(kt) in Latin America(developing only) in 1967 to that in 1970?
Make the answer very short. 0.77. What is the ratio of the Emissions(kt) in China in 1967 to that in 1970?
Give a very brief answer. 0.56. What is the ratio of the Emissions(kt) of Philippines in 1967 to that in 1970?
Ensure brevity in your answer.  0.74. What is the ratio of the Emissions(kt) of Suriname in 1967 to that in 1970?
Offer a terse response. 0.83. What is the ratio of the Emissions(kt) of Latin America(developing only) in 1967 to that in 1971?
Offer a terse response. 0.7. What is the ratio of the Emissions(kt) in China in 1967 to that in 1971?
Ensure brevity in your answer.  0.49. What is the ratio of the Emissions(kt) of Philippines in 1967 to that in 1971?
Ensure brevity in your answer.  0.66. What is the ratio of the Emissions(kt) of Latin America(developing only) in 1967 to that in 1972?
Your answer should be compact. 0.66. What is the ratio of the Emissions(kt) in China in 1967 to that in 1972?
Your answer should be compact. 0.47. What is the ratio of the Emissions(kt) of Philippines in 1967 to that in 1972?
Give a very brief answer. 0.69. What is the ratio of the Emissions(kt) of Suriname in 1967 to that in 1972?
Offer a terse response. 0.76. What is the ratio of the Emissions(kt) in Latin America(developing only) in 1968 to that in 1969?
Provide a short and direct response. 0.92. What is the ratio of the Emissions(kt) of China in 1968 to that in 1969?
Offer a very short reply. 0.81. What is the ratio of the Emissions(kt) of Philippines in 1968 to that in 1969?
Make the answer very short. 0.97. What is the ratio of the Emissions(kt) in Suriname in 1968 to that in 1969?
Offer a very short reply. 0.95. What is the ratio of the Emissions(kt) in Latin America(developing only) in 1968 to that in 1970?
Offer a very short reply. 0.84. What is the ratio of the Emissions(kt) of China in 1968 to that in 1970?
Offer a terse response. 0.61. What is the ratio of the Emissions(kt) in Philippines in 1968 to that in 1970?
Make the answer very short. 0.9. What is the ratio of the Emissions(kt) of Suriname in 1968 to that in 1970?
Your answer should be very brief. 0.9. What is the ratio of the Emissions(kt) in Latin America(developing only) in 1968 to that in 1971?
Ensure brevity in your answer.  0.77. What is the ratio of the Emissions(kt) of China in 1968 to that in 1971?
Your response must be concise. 0.53. What is the ratio of the Emissions(kt) in Philippines in 1968 to that in 1971?
Make the answer very short. 0.81. What is the ratio of the Emissions(kt) in Suriname in 1968 to that in 1971?
Keep it short and to the point. 0.85. What is the ratio of the Emissions(kt) in Latin America(developing only) in 1968 to that in 1972?
Your answer should be very brief. 0.72. What is the ratio of the Emissions(kt) of China in 1968 to that in 1972?
Provide a short and direct response. 0.5. What is the ratio of the Emissions(kt) in Philippines in 1968 to that in 1972?
Your response must be concise. 0.84. What is the ratio of the Emissions(kt) of Suriname in 1968 to that in 1972?
Your answer should be very brief. 0.83. What is the ratio of the Emissions(kt) of Latin America(developing only) in 1969 to that in 1970?
Make the answer very short. 0.91. What is the ratio of the Emissions(kt) of China in 1969 to that in 1970?
Make the answer very short. 0.75. What is the ratio of the Emissions(kt) in Philippines in 1969 to that in 1970?
Keep it short and to the point. 0.92. What is the ratio of the Emissions(kt) of Suriname in 1969 to that in 1970?
Ensure brevity in your answer.  0.95. What is the ratio of the Emissions(kt) in Latin America(developing only) in 1969 to that in 1971?
Offer a very short reply. 0.83. What is the ratio of the Emissions(kt) of China in 1969 to that in 1971?
Provide a succinct answer. 0.66. What is the ratio of the Emissions(kt) in Philippines in 1969 to that in 1971?
Give a very brief answer. 0.83. What is the ratio of the Emissions(kt) in Suriname in 1969 to that in 1971?
Provide a short and direct response. 0.89. What is the ratio of the Emissions(kt) in Latin America(developing only) in 1969 to that in 1972?
Ensure brevity in your answer.  0.77. What is the ratio of the Emissions(kt) of China in 1969 to that in 1972?
Your answer should be very brief. 0.62. What is the ratio of the Emissions(kt) of Philippines in 1969 to that in 1972?
Make the answer very short. 0.86. What is the ratio of the Emissions(kt) of Suriname in 1969 to that in 1972?
Provide a short and direct response. 0.87. What is the ratio of the Emissions(kt) of Latin America(developing only) in 1970 to that in 1971?
Provide a short and direct response. 0.92. What is the ratio of the Emissions(kt) of China in 1970 to that in 1971?
Provide a short and direct response. 0.88. What is the ratio of the Emissions(kt) of Philippines in 1970 to that in 1971?
Offer a terse response. 0.9. What is the ratio of the Emissions(kt) of Suriname in 1970 to that in 1971?
Ensure brevity in your answer.  0.94. What is the ratio of the Emissions(kt) in Latin America(developing only) in 1970 to that in 1972?
Keep it short and to the point. 0.86. What is the ratio of the Emissions(kt) of China in 1970 to that in 1972?
Give a very brief answer. 0.83. What is the ratio of the Emissions(kt) of Philippines in 1970 to that in 1972?
Offer a terse response. 0.94. What is the ratio of the Emissions(kt) in Suriname in 1970 to that in 1972?
Offer a very short reply. 0.92. What is the ratio of the Emissions(kt) in Latin America(developing only) in 1971 to that in 1972?
Offer a terse response. 0.93. What is the ratio of the Emissions(kt) in China in 1971 to that in 1972?
Offer a terse response. 0.94. What is the ratio of the Emissions(kt) in Philippines in 1971 to that in 1972?
Provide a short and direct response. 1.04. What is the ratio of the Emissions(kt) of Suriname in 1971 to that in 1972?
Offer a very short reply. 0.98. What is the difference between the highest and the second highest Emissions(kt) in Latin America(developing only)?
Keep it short and to the point. 2.37e+04. What is the difference between the highest and the second highest Emissions(kt) of China?
Provide a short and direct response. 5.49e+04. What is the difference between the highest and the second highest Emissions(kt) in Philippines?
Offer a terse response. 1144.1. What is the difference between the highest and the second highest Emissions(kt) of Suriname?
Keep it short and to the point. 29.34. What is the difference between the highest and the lowest Emissions(kt) of Latin America(developing only)?
Your answer should be compact. 1.36e+05. What is the difference between the highest and the lowest Emissions(kt) in China?
Your response must be concise. 4.98e+05. What is the difference between the highest and the lowest Emissions(kt) in Philippines?
Make the answer very short. 1.15e+04. What is the difference between the highest and the lowest Emissions(kt) of Suriname?
Provide a succinct answer. 649.06. 